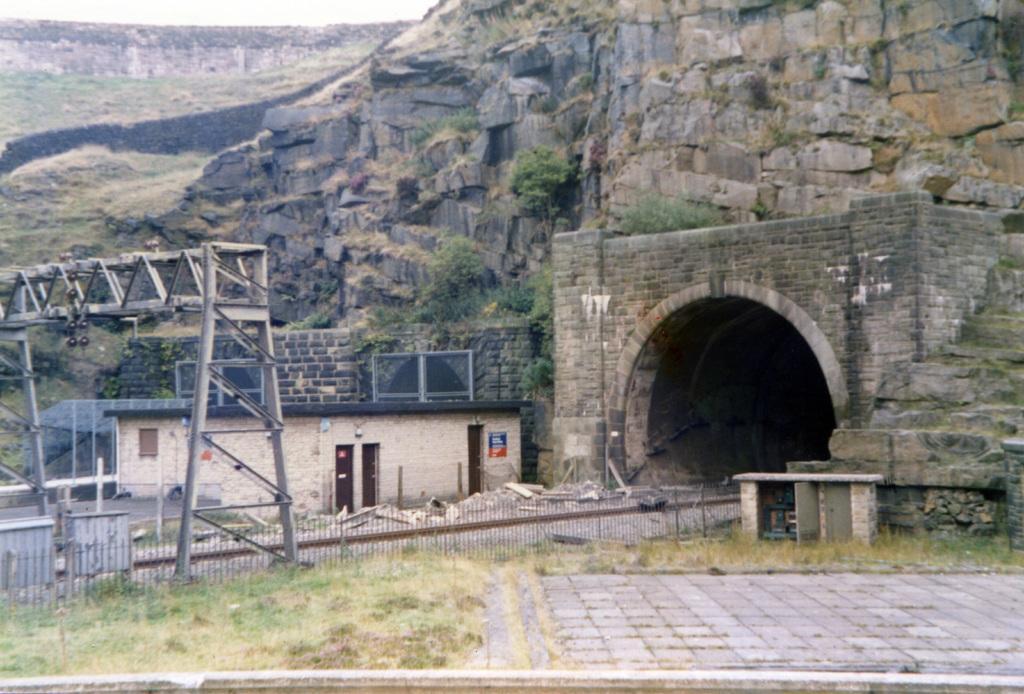Please provide a concise description of this image. In this image I can see grass, fed poles, a building and over there I can see a tunnel. 